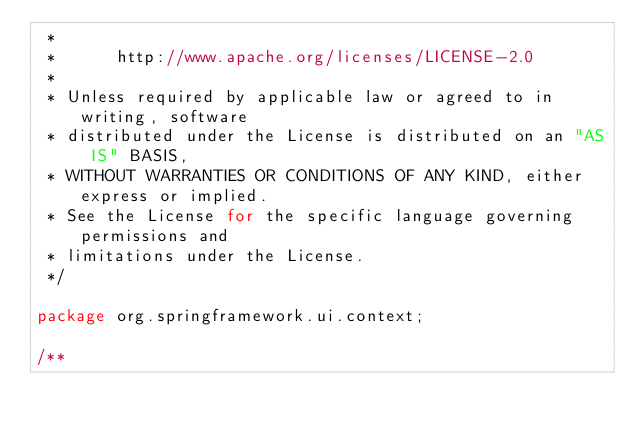<code> <loc_0><loc_0><loc_500><loc_500><_Java_> * 
 *      http://www.apache.org/licenses/LICENSE-2.0
 * 
 * Unless required by applicable law or agreed to in writing, software
 * distributed under the License is distributed on an "AS IS" BASIS,
 * WITHOUT WARRANTIES OR CONDITIONS OF ANY KIND, either express or implied.
 * See the License for the specific language governing permissions and
 * limitations under the License.
 */ 

package org.springframework.ui.context;

/**</code> 